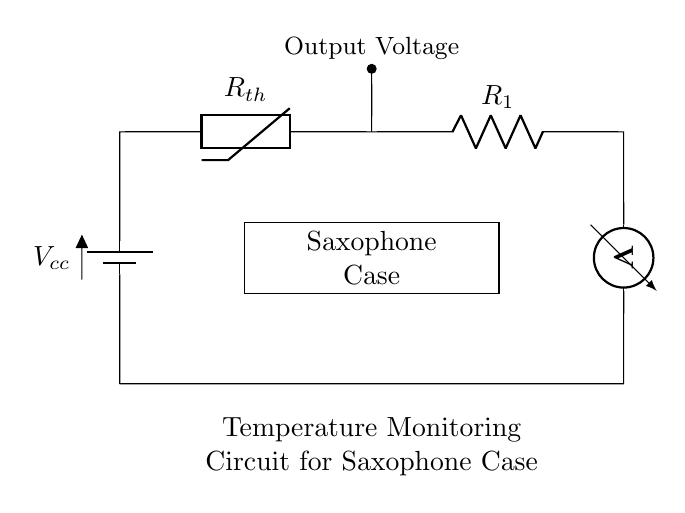What component is used to monitor temperature? The thermistor is specifically designed to change its resistance based on temperature, making it the component responsible for temperature monitoring in this circuit.
Answer: thermistor What type of circuit is represented in the diagram? The circuit is a series circuit, as indicated by the single path for the current flow from the battery through the components and back to the battery.
Answer: series circuit What is the output of the circuit? The output voltage is taken from the point at the thermistor; it represents the voltage that varies with temperature changes detected by the thermistor.
Answer: Output Voltage In what type of environment is this circuit likely used? The saxophone case is the intended environment, as the circuit is specifically designed to monitor the temperature inside the case to protect the saxophone from damage.
Answer: saxophone case What does the resistor labeled R1 do in the circuit? Resistor R1 is used in the circuit to control the current flow along with the thermistor, influencing the voltage output based on the temperature changes detected.
Answer: control current What happens to the voltage output if the temperature increases? As the temperature increases, the resistance of the thermistor typically decreases, which alters the voltage across the thermistor and R1, leading to a change in output voltage.
Answer: voltage decreases What is the role of the battery in this circuit? The battery provides the necessary power (voltage) for the entire circuit to function, enabling current flow through the components.
Answer: power supply 